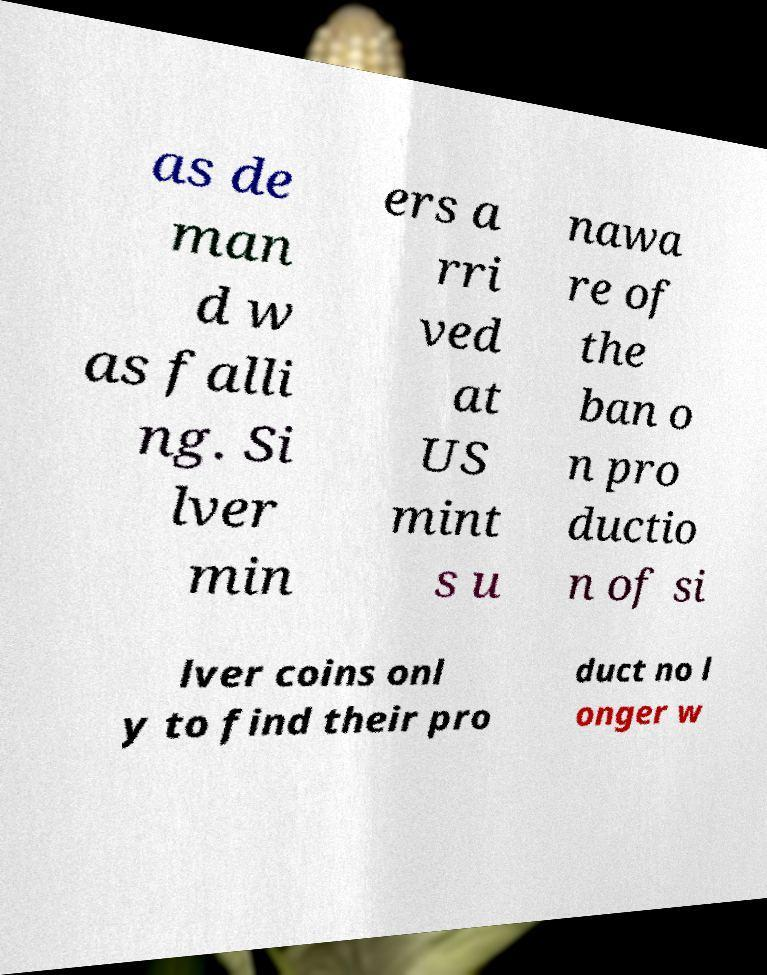I need the written content from this picture converted into text. Can you do that? as de man d w as falli ng. Si lver min ers a rri ved at US mint s u nawa re of the ban o n pro ductio n of si lver coins onl y to find their pro duct no l onger w 